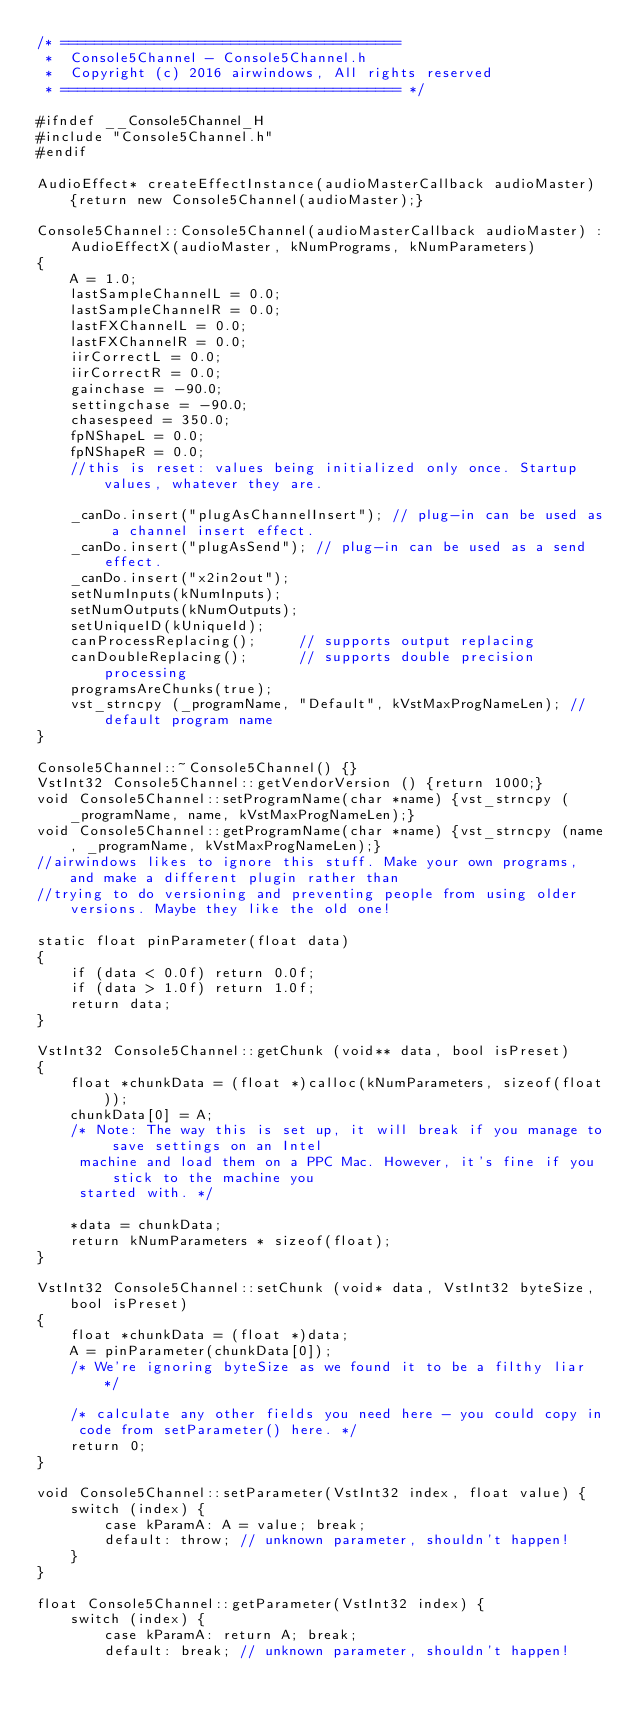<code> <loc_0><loc_0><loc_500><loc_500><_C++_>/* ========================================
 *  Console5Channel - Console5Channel.h
 *  Copyright (c) 2016 airwindows, All rights reserved
 * ======================================== */

#ifndef __Console5Channel_H
#include "Console5Channel.h"
#endif

AudioEffect* createEffectInstance(audioMasterCallback audioMaster) {return new Console5Channel(audioMaster);}

Console5Channel::Console5Channel(audioMasterCallback audioMaster) :
    AudioEffectX(audioMaster, kNumPrograms, kNumParameters)
{
	A = 1.0;
	lastSampleChannelL = 0.0;
	lastSampleChannelR = 0.0;
	lastFXChannelL = 0.0;
	lastFXChannelR = 0.0;
	iirCorrectL = 0.0;
	iirCorrectR = 0.0;
	gainchase = -90.0;
	settingchase = -90.0;
	chasespeed = 350.0;	
	fpNShapeL = 0.0;
	fpNShapeR = 0.0;
	//this is reset: values being initialized only once. Startup values, whatever they are.
	
    _canDo.insert("plugAsChannelInsert"); // plug-in can be used as a channel insert effect.
    _canDo.insert("plugAsSend"); // plug-in can be used as a send effect.
    _canDo.insert("x2in2out"); 
    setNumInputs(kNumInputs);
    setNumOutputs(kNumOutputs);
    setUniqueID(kUniqueId);
    canProcessReplacing();     // supports output replacing
    canDoubleReplacing();      // supports double precision processing
	programsAreChunks(true);
    vst_strncpy (_programName, "Default", kVstMaxProgNameLen); // default program name
}

Console5Channel::~Console5Channel() {}
VstInt32 Console5Channel::getVendorVersion () {return 1000;}
void Console5Channel::setProgramName(char *name) {vst_strncpy (_programName, name, kVstMaxProgNameLen);}
void Console5Channel::getProgramName(char *name) {vst_strncpy (name, _programName, kVstMaxProgNameLen);}
//airwindows likes to ignore this stuff. Make your own programs, and make a different plugin rather than
//trying to do versioning and preventing people from using older versions. Maybe they like the old one!

static float pinParameter(float data)
{
	if (data < 0.0f) return 0.0f;
	if (data > 1.0f) return 1.0f;
	return data;
}

VstInt32 Console5Channel::getChunk (void** data, bool isPreset)
{
	float *chunkData = (float *)calloc(kNumParameters, sizeof(float));
	chunkData[0] = A;
	/* Note: The way this is set up, it will break if you manage to save settings on an Intel
	 machine and load them on a PPC Mac. However, it's fine if you stick to the machine you 
	 started with. */
	
	*data = chunkData;
	return kNumParameters * sizeof(float);
}

VstInt32 Console5Channel::setChunk (void* data, VstInt32 byteSize, bool isPreset)
{	
	float *chunkData = (float *)data;
	A = pinParameter(chunkData[0]);
	/* We're ignoring byteSize as we found it to be a filthy liar */
	
	/* calculate any other fields you need here - you could copy in 
	 code from setParameter() here. */
	return 0;
}

void Console5Channel::setParameter(VstInt32 index, float value) {
    switch (index) {
        case kParamA: A = value; break;
        default: throw; // unknown parameter, shouldn't happen!
    }
}

float Console5Channel::getParameter(VstInt32 index) {
    switch (index) {
        case kParamA: return A; break;
        default: break; // unknown parameter, shouldn't happen!</code> 